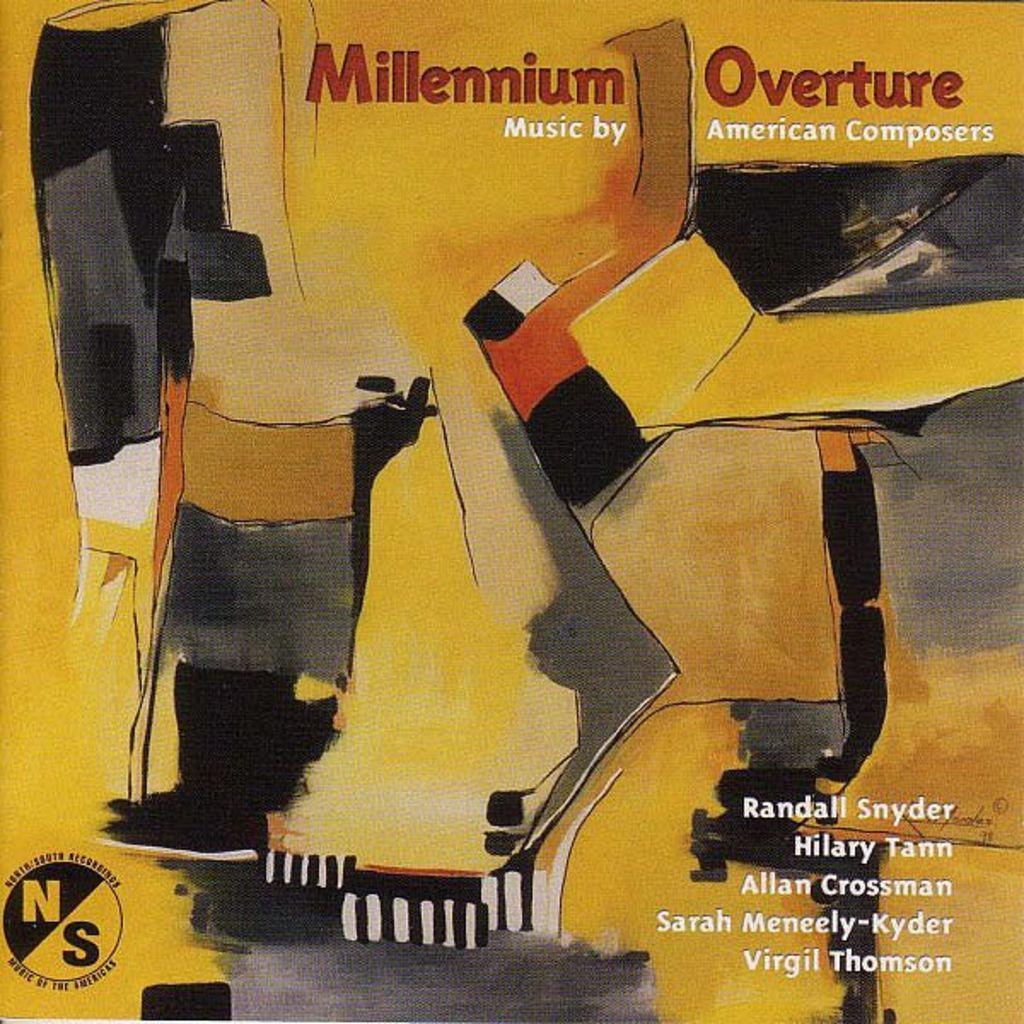<image>
Provide a brief description of the given image. The album titled Millennium Overture features music by several different American composers. 